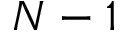Convert formula to latex. <formula><loc_0><loc_0><loc_500><loc_500>N - 1</formula> 